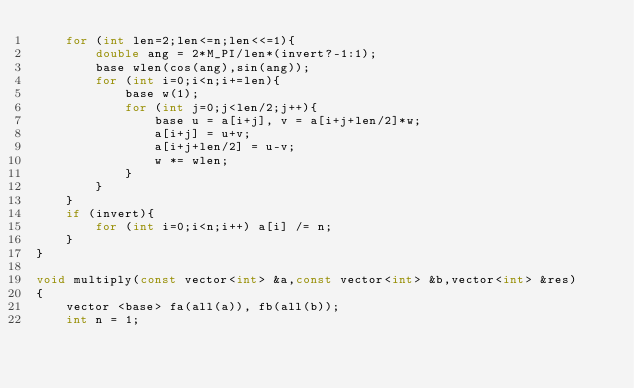<code> <loc_0><loc_0><loc_500><loc_500><_C++_>    for (int len=2;len<=n;len<<=1){
        double ang = 2*M_PI/len*(invert?-1:1);
        base wlen(cos(ang),sin(ang));
        for (int i=0;i<n;i+=len){
            base w(1);
            for (int j=0;j<len/2;j++){
                base u = a[i+j], v = a[i+j+len/2]*w;
                a[i+j] = u+v;
                a[i+j+len/2] = u-v;
                w *= wlen;
            }
        }
    }
    if (invert){
        for (int i=0;i<n;i++) a[i] /= n;
    }
}
 
void multiply(const vector<int> &a,const vector<int> &b,vector<int> &res)
{
    vector <base> fa(all(a)), fb(all(b));
    int n = 1;</code> 